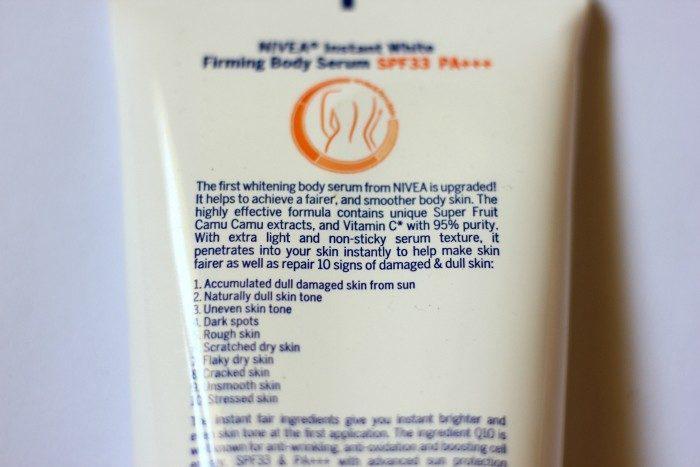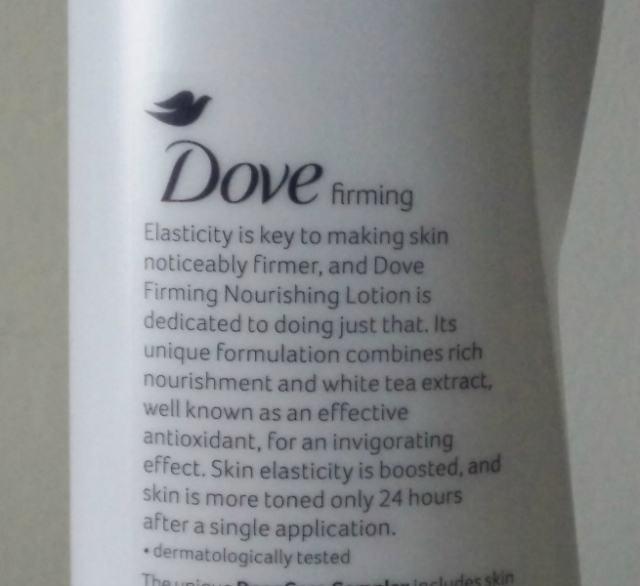The first image is the image on the left, the second image is the image on the right. Given the left and right images, does the statement "In the image on the right, the bottle of soap has a top pump dispenser." hold true? Answer yes or no. No. The first image is the image on the left, the second image is the image on the right. Analyze the images presented: Is the assertion "The right image contains one pump-top product with its nozzle facing left, and the left image contains a product without a pump top." valid? Answer yes or no. No. 